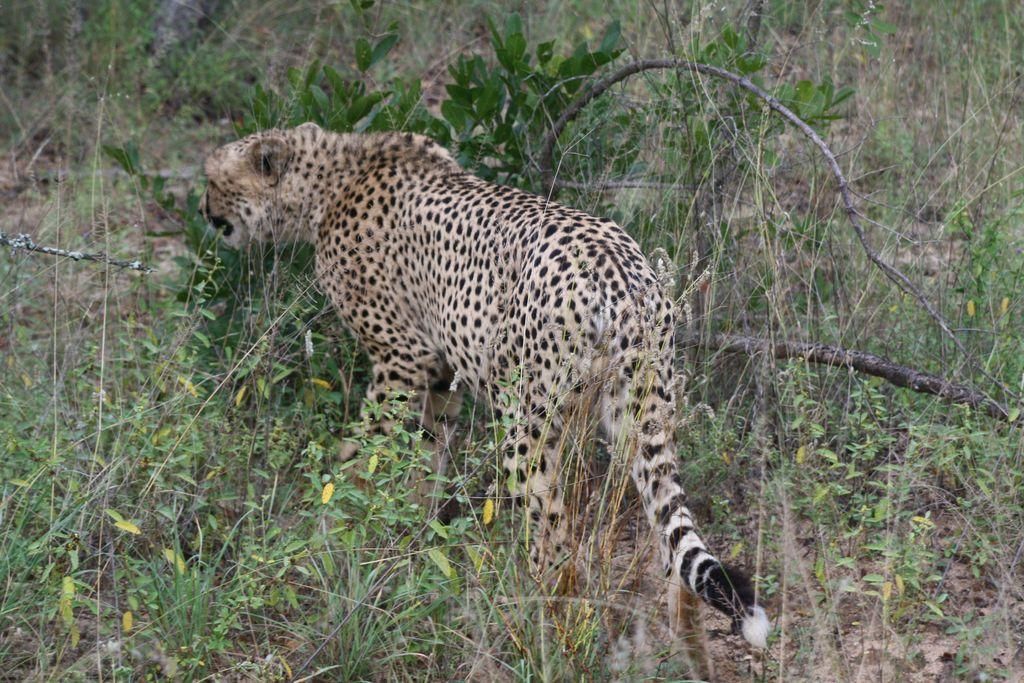What type of animal is in the image? There is a cheetah in the image. Where is the cheetah located? The cheetah is on the ground. What type of vegetation is visible in the image? There is grass and plants visible in the image. What type of nerve can be seen in the image? There is no nerve present in the image; it features a cheetah on the ground with grass and plants. 